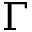<formula> <loc_0><loc_0><loc_500><loc_500>\Gamma</formula> 